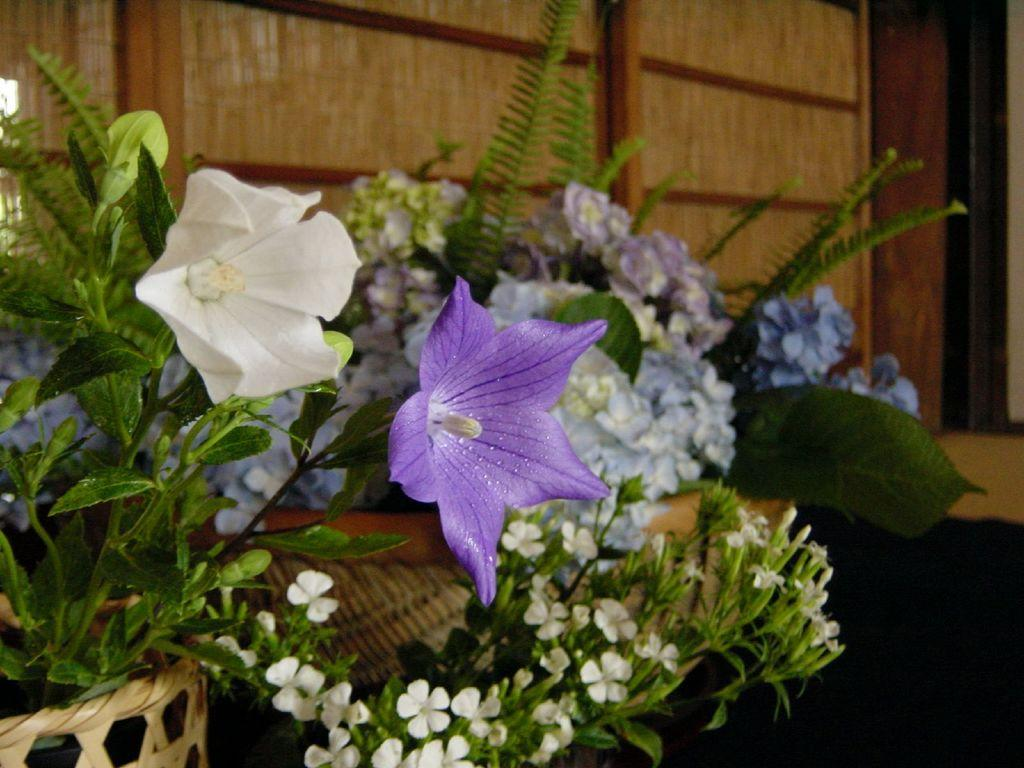What is located in the foreground of the image? There are flowers in the foreground of the image. How are the flowers arranged or contained in the image? The flowers are in a basket. What type of material can be seen in the background of the image? There is a wooden wall in the background of the image. What happens to the flowers when they burst in the image? There is no indication in the image that the flowers burst or experience any damage. 